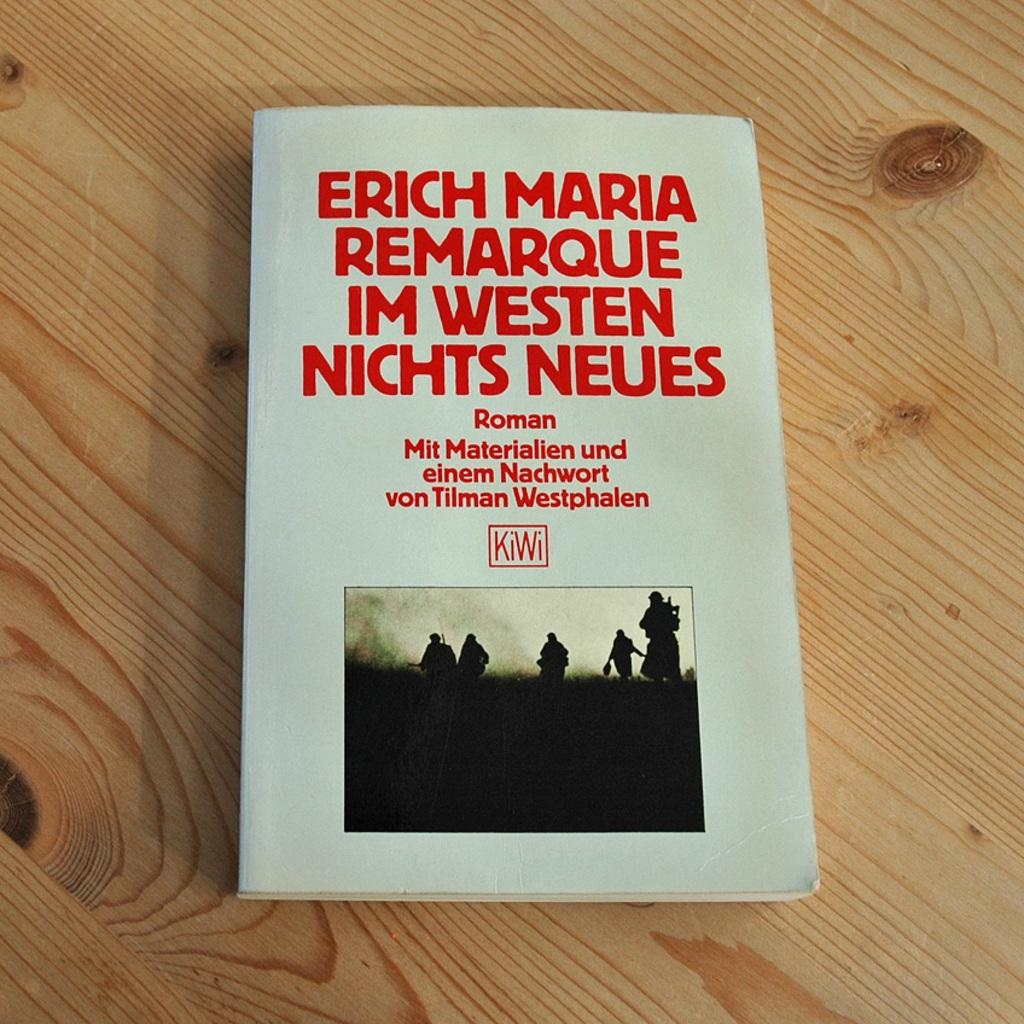<image>
Provide a brief description of the given image. The book Enrich Maria Remarque Im Westen Nichts Neues. 